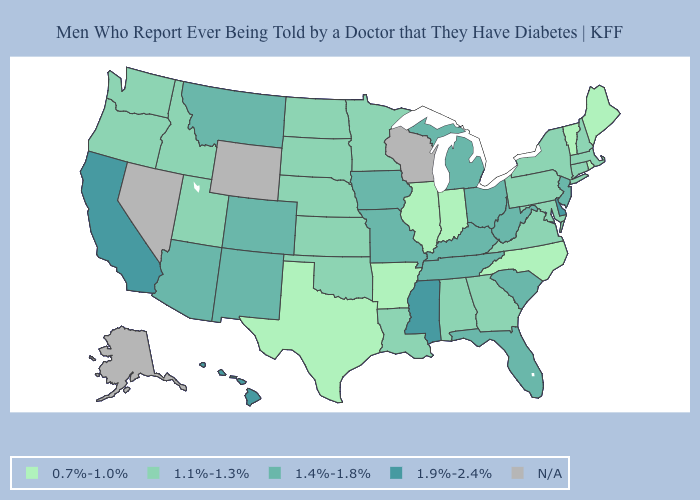Which states have the highest value in the USA?
Give a very brief answer. California, Delaware, Hawaii, Mississippi. What is the highest value in states that border Nebraska?
Give a very brief answer. 1.4%-1.8%. Which states have the lowest value in the Northeast?
Short answer required. Maine, Rhode Island, Vermont. What is the value of Delaware?
Be succinct. 1.9%-2.4%. Does Maine have the lowest value in the USA?
Concise answer only. Yes. Which states have the highest value in the USA?
Keep it brief. California, Delaware, Hawaii, Mississippi. What is the value of Rhode Island?
Write a very short answer. 0.7%-1.0%. Which states have the lowest value in the West?
Write a very short answer. Idaho, Oregon, Utah, Washington. What is the value of Oregon?
Answer briefly. 1.1%-1.3%. Name the states that have a value in the range 1.1%-1.3%?
Concise answer only. Alabama, Connecticut, Georgia, Idaho, Kansas, Louisiana, Maryland, Massachusetts, Minnesota, Nebraska, New Hampshire, New York, North Dakota, Oklahoma, Oregon, Pennsylvania, South Dakota, Utah, Virginia, Washington. Which states have the lowest value in the MidWest?
Answer briefly. Illinois, Indiana. Is the legend a continuous bar?
Give a very brief answer. No. Which states hav the highest value in the Northeast?
Concise answer only. New Jersey. Which states have the highest value in the USA?
Be succinct. California, Delaware, Hawaii, Mississippi. 